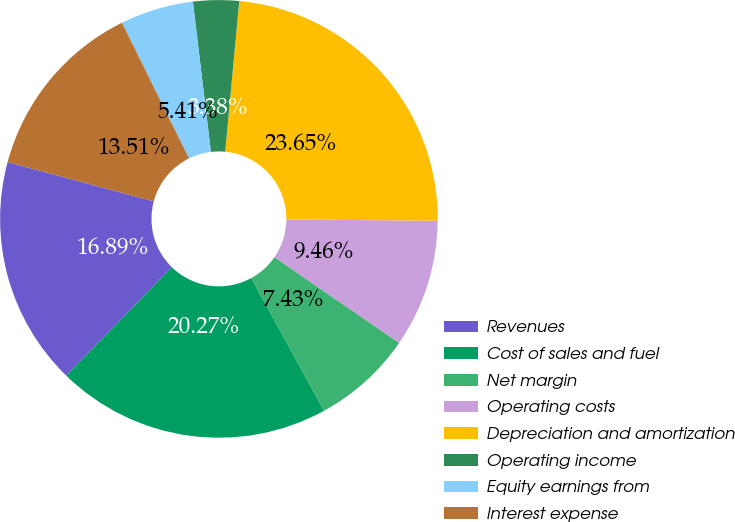Convert chart. <chart><loc_0><loc_0><loc_500><loc_500><pie_chart><fcel>Revenues<fcel>Cost of sales and fuel<fcel>Net margin<fcel>Operating costs<fcel>Depreciation and amortization<fcel>Operating income<fcel>Equity earnings from<fcel>Interest expense<nl><fcel>16.89%<fcel>20.27%<fcel>7.43%<fcel>9.46%<fcel>23.65%<fcel>3.38%<fcel>5.41%<fcel>13.51%<nl></chart> 